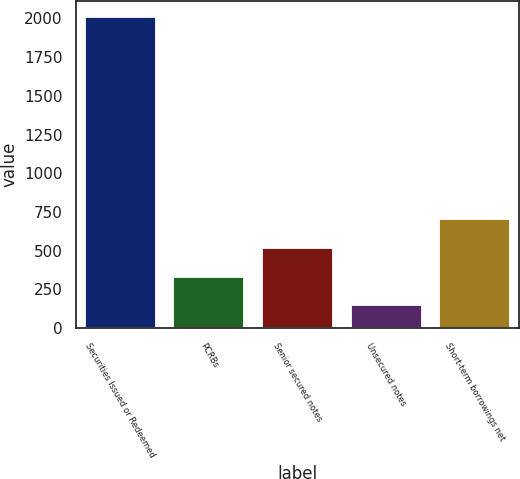Convert chart to OTSL. <chart><loc_0><loc_0><loc_500><loc_500><bar_chart><fcel>Securities Issued or Redeemed<fcel>PCRBs<fcel>Senior secured notes<fcel>Unsecured notes<fcel>Short-term borrowings net<nl><fcel>2011<fcel>333.4<fcel>519.8<fcel>147<fcel>706.2<nl></chart> 